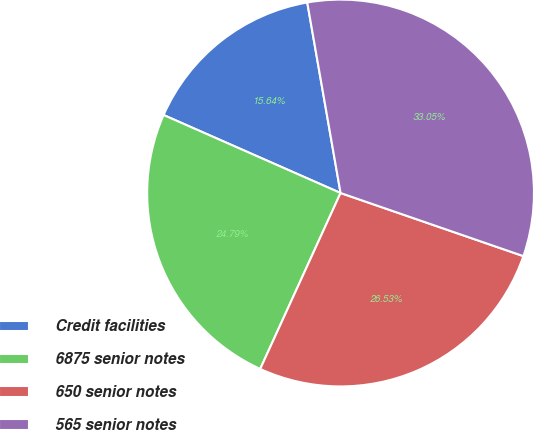Convert chart. <chart><loc_0><loc_0><loc_500><loc_500><pie_chart><fcel>Credit facilities<fcel>6875 senior notes<fcel>650 senior notes<fcel>565 senior notes<nl><fcel>15.64%<fcel>24.79%<fcel>26.53%<fcel>33.05%<nl></chart> 